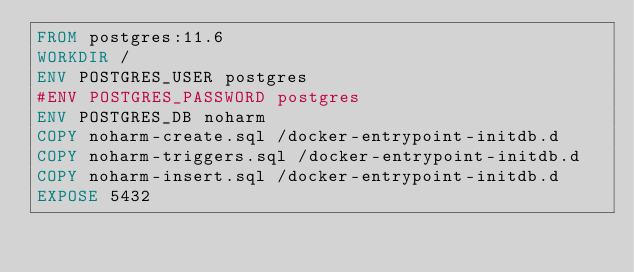<code> <loc_0><loc_0><loc_500><loc_500><_Dockerfile_>FROM postgres:11.6
WORKDIR /
ENV POSTGRES_USER postgres
#ENV POSTGRES_PASSWORD postgres
ENV POSTGRES_DB noharm
COPY noharm-create.sql /docker-entrypoint-initdb.d
COPY noharm-triggers.sql /docker-entrypoint-initdb.d
COPY noharm-insert.sql /docker-entrypoint-initdb.d
EXPOSE 5432</code> 